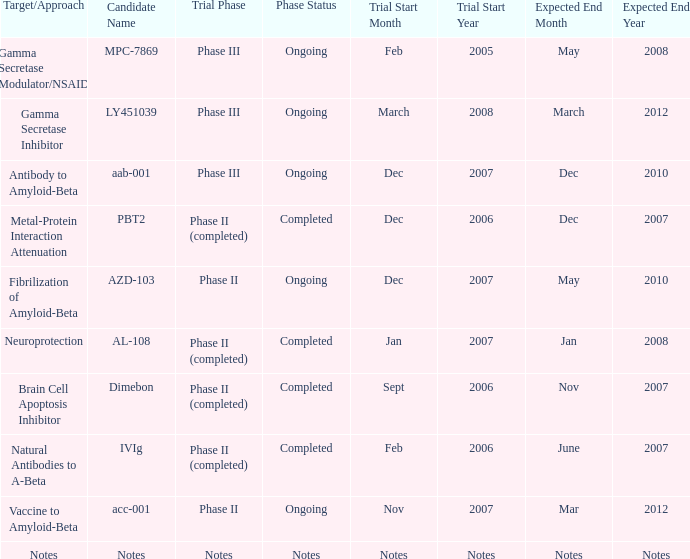If the candidate is named notes, when does the trial begin? Notes. 